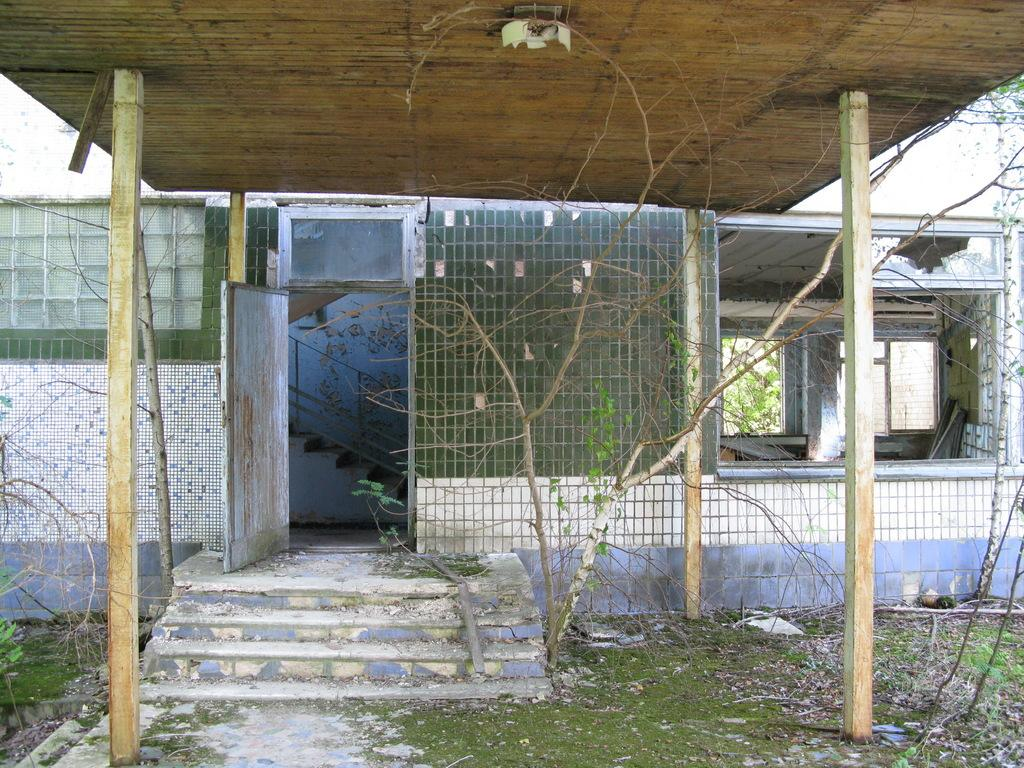What type of building is in the middle of the image? There is an old house in the middle of the image. What is located in front of the old house? There is a wooden shelter in front of the house. What type of surface is the floor made of? The floor has grass. What other material is present near the grass? There are stones beside the grass. How many passengers are inside the house in the image? There is no indication of passengers or people inside the house in the image. 